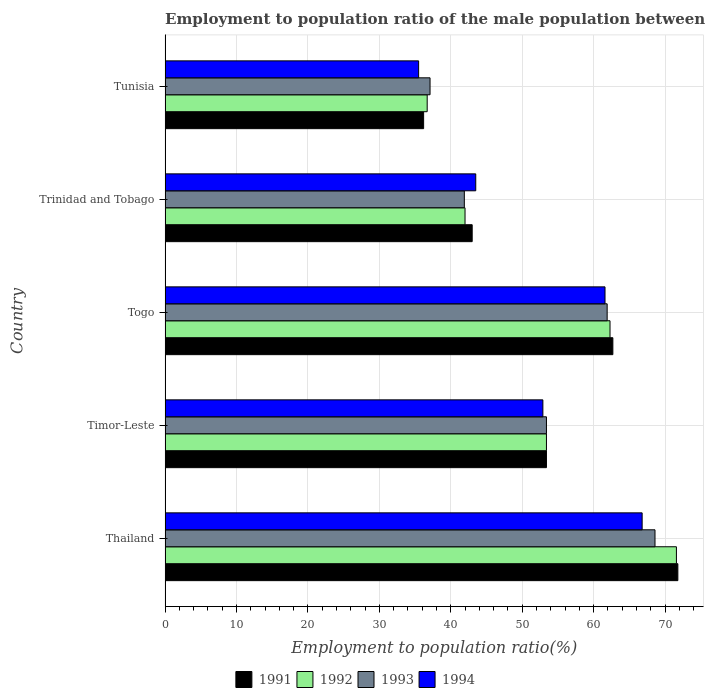How many different coloured bars are there?
Keep it short and to the point. 4. Are the number of bars per tick equal to the number of legend labels?
Ensure brevity in your answer.  Yes. What is the label of the 5th group of bars from the top?
Keep it short and to the point. Thailand. In how many cases, is the number of bars for a given country not equal to the number of legend labels?
Ensure brevity in your answer.  0. What is the employment to population ratio in 1992 in Timor-Leste?
Your response must be concise. 53.4. Across all countries, what is the maximum employment to population ratio in 1993?
Make the answer very short. 68.6. Across all countries, what is the minimum employment to population ratio in 1992?
Give a very brief answer. 36.7. In which country was the employment to population ratio in 1993 maximum?
Give a very brief answer. Thailand. In which country was the employment to population ratio in 1993 minimum?
Your answer should be very brief. Tunisia. What is the total employment to population ratio in 1991 in the graph?
Offer a very short reply. 267.1. What is the difference between the employment to population ratio in 1991 in Trinidad and Tobago and that in Tunisia?
Offer a terse response. 6.8. What is the difference between the employment to population ratio in 1992 in Timor-Leste and the employment to population ratio in 1993 in Trinidad and Tobago?
Keep it short and to the point. 11.5. What is the average employment to population ratio in 1994 per country?
Provide a succinct answer. 52.06. What is the difference between the employment to population ratio in 1991 and employment to population ratio in 1993 in Thailand?
Give a very brief answer. 3.2. What is the ratio of the employment to population ratio in 1993 in Thailand to that in Tunisia?
Provide a succinct answer. 1.85. Is the difference between the employment to population ratio in 1991 in Thailand and Togo greater than the difference between the employment to population ratio in 1993 in Thailand and Togo?
Your response must be concise. Yes. What is the difference between the highest and the second highest employment to population ratio in 1993?
Offer a very short reply. 6.7. What is the difference between the highest and the lowest employment to population ratio in 1993?
Offer a very short reply. 31.5. In how many countries, is the employment to population ratio in 1992 greater than the average employment to population ratio in 1992 taken over all countries?
Your answer should be compact. 3. Is the sum of the employment to population ratio in 1991 in Thailand and Togo greater than the maximum employment to population ratio in 1993 across all countries?
Ensure brevity in your answer.  Yes. What does the 1st bar from the bottom in Togo represents?
Offer a very short reply. 1991. Is it the case that in every country, the sum of the employment to population ratio in 1994 and employment to population ratio in 1992 is greater than the employment to population ratio in 1991?
Offer a terse response. Yes. Does the graph contain any zero values?
Your response must be concise. No. Does the graph contain grids?
Your response must be concise. Yes. How many legend labels are there?
Your answer should be compact. 4. What is the title of the graph?
Make the answer very short. Employment to population ratio of the male population between the ages 0 to 14. Does "1983" appear as one of the legend labels in the graph?
Keep it short and to the point. No. What is the Employment to population ratio(%) of 1991 in Thailand?
Ensure brevity in your answer.  71.8. What is the Employment to population ratio(%) in 1992 in Thailand?
Provide a short and direct response. 71.6. What is the Employment to population ratio(%) of 1993 in Thailand?
Offer a terse response. 68.6. What is the Employment to population ratio(%) of 1994 in Thailand?
Provide a succinct answer. 66.8. What is the Employment to population ratio(%) in 1991 in Timor-Leste?
Offer a very short reply. 53.4. What is the Employment to population ratio(%) of 1992 in Timor-Leste?
Offer a very short reply. 53.4. What is the Employment to population ratio(%) in 1993 in Timor-Leste?
Ensure brevity in your answer.  53.4. What is the Employment to population ratio(%) of 1994 in Timor-Leste?
Your answer should be very brief. 52.9. What is the Employment to population ratio(%) in 1991 in Togo?
Keep it short and to the point. 62.7. What is the Employment to population ratio(%) of 1992 in Togo?
Make the answer very short. 62.3. What is the Employment to population ratio(%) of 1993 in Togo?
Keep it short and to the point. 61.9. What is the Employment to population ratio(%) of 1994 in Togo?
Offer a terse response. 61.6. What is the Employment to population ratio(%) of 1991 in Trinidad and Tobago?
Your response must be concise. 43. What is the Employment to population ratio(%) of 1993 in Trinidad and Tobago?
Give a very brief answer. 41.9. What is the Employment to population ratio(%) of 1994 in Trinidad and Tobago?
Your response must be concise. 43.5. What is the Employment to population ratio(%) of 1991 in Tunisia?
Provide a succinct answer. 36.2. What is the Employment to population ratio(%) of 1992 in Tunisia?
Offer a very short reply. 36.7. What is the Employment to population ratio(%) in 1993 in Tunisia?
Your response must be concise. 37.1. What is the Employment to population ratio(%) in 1994 in Tunisia?
Provide a succinct answer. 35.5. Across all countries, what is the maximum Employment to population ratio(%) of 1991?
Your answer should be compact. 71.8. Across all countries, what is the maximum Employment to population ratio(%) in 1992?
Offer a very short reply. 71.6. Across all countries, what is the maximum Employment to population ratio(%) in 1993?
Your answer should be compact. 68.6. Across all countries, what is the maximum Employment to population ratio(%) in 1994?
Your answer should be very brief. 66.8. Across all countries, what is the minimum Employment to population ratio(%) of 1991?
Ensure brevity in your answer.  36.2. Across all countries, what is the minimum Employment to population ratio(%) in 1992?
Ensure brevity in your answer.  36.7. Across all countries, what is the minimum Employment to population ratio(%) of 1993?
Offer a very short reply. 37.1. Across all countries, what is the minimum Employment to population ratio(%) of 1994?
Provide a short and direct response. 35.5. What is the total Employment to population ratio(%) in 1991 in the graph?
Make the answer very short. 267.1. What is the total Employment to population ratio(%) in 1992 in the graph?
Your answer should be very brief. 266. What is the total Employment to population ratio(%) in 1993 in the graph?
Ensure brevity in your answer.  262.9. What is the total Employment to population ratio(%) in 1994 in the graph?
Provide a short and direct response. 260.3. What is the difference between the Employment to population ratio(%) in 1992 in Thailand and that in Timor-Leste?
Your answer should be very brief. 18.2. What is the difference between the Employment to population ratio(%) of 1991 in Thailand and that in Togo?
Your response must be concise. 9.1. What is the difference between the Employment to population ratio(%) in 1992 in Thailand and that in Togo?
Provide a succinct answer. 9.3. What is the difference between the Employment to population ratio(%) of 1994 in Thailand and that in Togo?
Provide a short and direct response. 5.2. What is the difference between the Employment to population ratio(%) in 1991 in Thailand and that in Trinidad and Tobago?
Make the answer very short. 28.8. What is the difference between the Employment to population ratio(%) of 1992 in Thailand and that in Trinidad and Tobago?
Offer a very short reply. 29.6. What is the difference between the Employment to population ratio(%) of 1993 in Thailand and that in Trinidad and Tobago?
Provide a short and direct response. 26.7. What is the difference between the Employment to population ratio(%) in 1994 in Thailand and that in Trinidad and Tobago?
Your response must be concise. 23.3. What is the difference between the Employment to population ratio(%) of 1991 in Thailand and that in Tunisia?
Make the answer very short. 35.6. What is the difference between the Employment to population ratio(%) of 1992 in Thailand and that in Tunisia?
Provide a short and direct response. 34.9. What is the difference between the Employment to population ratio(%) of 1993 in Thailand and that in Tunisia?
Keep it short and to the point. 31.5. What is the difference between the Employment to population ratio(%) of 1994 in Thailand and that in Tunisia?
Offer a terse response. 31.3. What is the difference between the Employment to population ratio(%) of 1993 in Timor-Leste and that in Togo?
Provide a short and direct response. -8.5. What is the difference between the Employment to population ratio(%) in 1994 in Timor-Leste and that in Togo?
Your response must be concise. -8.7. What is the difference between the Employment to population ratio(%) of 1991 in Timor-Leste and that in Trinidad and Tobago?
Keep it short and to the point. 10.4. What is the difference between the Employment to population ratio(%) of 1992 in Timor-Leste and that in Trinidad and Tobago?
Ensure brevity in your answer.  11.4. What is the difference between the Employment to population ratio(%) in 1993 in Timor-Leste and that in Trinidad and Tobago?
Ensure brevity in your answer.  11.5. What is the difference between the Employment to population ratio(%) of 1992 in Timor-Leste and that in Tunisia?
Keep it short and to the point. 16.7. What is the difference between the Employment to population ratio(%) of 1993 in Timor-Leste and that in Tunisia?
Offer a terse response. 16.3. What is the difference between the Employment to population ratio(%) in 1991 in Togo and that in Trinidad and Tobago?
Provide a short and direct response. 19.7. What is the difference between the Employment to population ratio(%) in 1992 in Togo and that in Trinidad and Tobago?
Make the answer very short. 20.3. What is the difference between the Employment to population ratio(%) in 1993 in Togo and that in Trinidad and Tobago?
Keep it short and to the point. 20. What is the difference between the Employment to population ratio(%) in 1992 in Togo and that in Tunisia?
Your answer should be very brief. 25.6. What is the difference between the Employment to population ratio(%) in 1993 in Togo and that in Tunisia?
Give a very brief answer. 24.8. What is the difference between the Employment to population ratio(%) of 1994 in Togo and that in Tunisia?
Give a very brief answer. 26.1. What is the difference between the Employment to population ratio(%) of 1991 in Trinidad and Tobago and that in Tunisia?
Make the answer very short. 6.8. What is the difference between the Employment to population ratio(%) in 1991 in Thailand and the Employment to population ratio(%) in 1994 in Timor-Leste?
Your answer should be compact. 18.9. What is the difference between the Employment to population ratio(%) in 1992 in Thailand and the Employment to population ratio(%) in 1993 in Timor-Leste?
Give a very brief answer. 18.2. What is the difference between the Employment to population ratio(%) of 1992 in Thailand and the Employment to population ratio(%) of 1994 in Timor-Leste?
Keep it short and to the point. 18.7. What is the difference between the Employment to population ratio(%) of 1991 in Thailand and the Employment to population ratio(%) of 1992 in Togo?
Keep it short and to the point. 9.5. What is the difference between the Employment to population ratio(%) of 1991 in Thailand and the Employment to population ratio(%) of 1994 in Togo?
Your response must be concise. 10.2. What is the difference between the Employment to population ratio(%) of 1992 in Thailand and the Employment to population ratio(%) of 1993 in Togo?
Keep it short and to the point. 9.7. What is the difference between the Employment to population ratio(%) of 1991 in Thailand and the Employment to population ratio(%) of 1992 in Trinidad and Tobago?
Offer a terse response. 29.8. What is the difference between the Employment to population ratio(%) in 1991 in Thailand and the Employment to population ratio(%) in 1993 in Trinidad and Tobago?
Offer a very short reply. 29.9. What is the difference between the Employment to population ratio(%) in 1991 in Thailand and the Employment to population ratio(%) in 1994 in Trinidad and Tobago?
Offer a very short reply. 28.3. What is the difference between the Employment to population ratio(%) of 1992 in Thailand and the Employment to population ratio(%) of 1993 in Trinidad and Tobago?
Your answer should be very brief. 29.7. What is the difference between the Employment to population ratio(%) in 1992 in Thailand and the Employment to population ratio(%) in 1994 in Trinidad and Tobago?
Your answer should be compact. 28.1. What is the difference between the Employment to population ratio(%) of 1993 in Thailand and the Employment to population ratio(%) of 1994 in Trinidad and Tobago?
Keep it short and to the point. 25.1. What is the difference between the Employment to population ratio(%) in 1991 in Thailand and the Employment to population ratio(%) in 1992 in Tunisia?
Keep it short and to the point. 35.1. What is the difference between the Employment to population ratio(%) of 1991 in Thailand and the Employment to population ratio(%) of 1993 in Tunisia?
Give a very brief answer. 34.7. What is the difference between the Employment to population ratio(%) in 1991 in Thailand and the Employment to population ratio(%) in 1994 in Tunisia?
Give a very brief answer. 36.3. What is the difference between the Employment to population ratio(%) of 1992 in Thailand and the Employment to population ratio(%) of 1993 in Tunisia?
Give a very brief answer. 34.5. What is the difference between the Employment to population ratio(%) in 1992 in Thailand and the Employment to population ratio(%) in 1994 in Tunisia?
Offer a very short reply. 36.1. What is the difference between the Employment to population ratio(%) of 1993 in Thailand and the Employment to population ratio(%) of 1994 in Tunisia?
Your response must be concise. 33.1. What is the difference between the Employment to population ratio(%) in 1991 in Timor-Leste and the Employment to population ratio(%) in 1992 in Togo?
Your response must be concise. -8.9. What is the difference between the Employment to population ratio(%) in 1992 in Timor-Leste and the Employment to population ratio(%) in 1993 in Togo?
Offer a terse response. -8.5. What is the difference between the Employment to population ratio(%) in 1992 in Timor-Leste and the Employment to population ratio(%) in 1994 in Togo?
Your response must be concise. -8.2. What is the difference between the Employment to population ratio(%) in 1991 in Timor-Leste and the Employment to population ratio(%) in 1992 in Trinidad and Tobago?
Make the answer very short. 11.4. What is the difference between the Employment to population ratio(%) of 1992 in Timor-Leste and the Employment to population ratio(%) of 1994 in Trinidad and Tobago?
Your response must be concise. 9.9. What is the difference between the Employment to population ratio(%) in 1993 in Timor-Leste and the Employment to population ratio(%) in 1994 in Trinidad and Tobago?
Your answer should be compact. 9.9. What is the difference between the Employment to population ratio(%) of 1991 in Timor-Leste and the Employment to population ratio(%) of 1993 in Tunisia?
Make the answer very short. 16.3. What is the difference between the Employment to population ratio(%) in 1991 in Timor-Leste and the Employment to population ratio(%) in 1994 in Tunisia?
Keep it short and to the point. 17.9. What is the difference between the Employment to population ratio(%) in 1992 in Timor-Leste and the Employment to population ratio(%) in 1994 in Tunisia?
Keep it short and to the point. 17.9. What is the difference between the Employment to population ratio(%) of 1991 in Togo and the Employment to population ratio(%) of 1992 in Trinidad and Tobago?
Your answer should be very brief. 20.7. What is the difference between the Employment to population ratio(%) of 1991 in Togo and the Employment to population ratio(%) of 1993 in Trinidad and Tobago?
Your answer should be compact. 20.8. What is the difference between the Employment to population ratio(%) in 1991 in Togo and the Employment to population ratio(%) in 1994 in Trinidad and Tobago?
Keep it short and to the point. 19.2. What is the difference between the Employment to population ratio(%) of 1992 in Togo and the Employment to population ratio(%) of 1993 in Trinidad and Tobago?
Offer a terse response. 20.4. What is the difference between the Employment to population ratio(%) in 1993 in Togo and the Employment to population ratio(%) in 1994 in Trinidad and Tobago?
Keep it short and to the point. 18.4. What is the difference between the Employment to population ratio(%) of 1991 in Togo and the Employment to population ratio(%) of 1992 in Tunisia?
Ensure brevity in your answer.  26. What is the difference between the Employment to population ratio(%) of 1991 in Togo and the Employment to population ratio(%) of 1993 in Tunisia?
Give a very brief answer. 25.6. What is the difference between the Employment to population ratio(%) of 1991 in Togo and the Employment to population ratio(%) of 1994 in Tunisia?
Offer a very short reply. 27.2. What is the difference between the Employment to population ratio(%) of 1992 in Togo and the Employment to population ratio(%) of 1993 in Tunisia?
Provide a short and direct response. 25.2. What is the difference between the Employment to population ratio(%) of 1992 in Togo and the Employment to population ratio(%) of 1994 in Tunisia?
Your answer should be very brief. 26.8. What is the difference between the Employment to population ratio(%) of 1993 in Togo and the Employment to population ratio(%) of 1994 in Tunisia?
Ensure brevity in your answer.  26.4. What is the difference between the Employment to population ratio(%) in 1992 in Trinidad and Tobago and the Employment to population ratio(%) in 1994 in Tunisia?
Ensure brevity in your answer.  6.5. What is the difference between the Employment to population ratio(%) of 1993 in Trinidad and Tobago and the Employment to population ratio(%) of 1994 in Tunisia?
Offer a very short reply. 6.4. What is the average Employment to population ratio(%) of 1991 per country?
Keep it short and to the point. 53.42. What is the average Employment to population ratio(%) in 1992 per country?
Give a very brief answer. 53.2. What is the average Employment to population ratio(%) in 1993 per country?
Provide a short and direct response. 52.58. What is the average Employment to population ratio(%) in 1994 per country?
Provide a succinct answer. 52.06. What is the difference between the Employment to population ratio(%) in 1991 and Employment to population ratio(%) in 1993 in Thailand?
Your answer should be compact. 3.2. What is the difference between the Employment to population ratio(%) of 1992 and Employment to population ratio(%) of 1993 in Thailand?
Provide a succinct answer. 3. What is the difference between the Employment to population ratio(%) of 1992 and Employment to population ratio(%) of 1994 in Thailand?
Offer a terse response. 4.8. What is the difference between the Employment to population ratio(%) in 1993 and Employment to population ratio(%) in 1994 in Thailand?
Keep it short and to the point. 1.8. What is the difference between the Employment to population ratio(%) in 1991 and Employment to population ratio(%) in 1993 in Timor-Leste?
Make the answer very short. 0. What is the difference between the Employment to population ratio(%) of 1991 and Employment to population ratio(%) of 1994 in Timor-Leste?
Offer a terse response. 0.5. What is the difference between the Employment to population ratio(%) of 1992 and Employment to population ratio(%) of 1994 in Timor-Leste?
Your answer should be very brief. 0.5. What is the difference between the Employment to population ratio(%) in 1993 and Employment to population ratio(%) in 1994 in Timor-Leste?
Ensure brevity in your answer.  0.5. What is the difference between the Employment to population ratio(%) of 1992 and Employment to population ratio(%) of 1994 in Togo?
Offer a terse response. 0.7. What is the difference between the Employment to population ratio(%) in 1991 and Employment to population ratio(%) in 1992 in Trinidad and Tobago?
Provide a succinct answer. 1. What is the difference between the Employment to population ratio(%) of 1991 and Employment to population ratio(%) of 1994 in Trinidad and Tobago?
Provide a short and direct response. -0.5. What is the difference between the Employment to population ratio(%) of 1992 and Employment to population ratio(%) of 1994 in Trinidad and Tobago?
Provide a short and direct response. -1.5. What is the difference between the Employment to population ratio(%) of 1991 and Employment to population ratio(%) of 1994 in Tunisia?
Your answer should be very brief. 0.7. What is the difference between the Employment to population ratio(%) in 1992 and Employment to population ratio(%) in 1993 in Tunisia?
Ensure brevity in your answer.  -0.4. What is the ratio of the Employment to population ratio(%) in 1991 in Thailand to that in Timor-Leste?
Provide a short and direct response. 1.34. What is the ratio of the Employment to population ratio(%) of 1992 in Thailand to that in Timor-Leste?
Provide a succinct answer. 1.34. What is the ratio of the Employment to population ratio(%) of 1993 in Thailand to that in Timor-Leste?
Provide a succinct answer. 1.28. What is the ratio of the Employment to population ratio(%) in 1994 in Thailand to that in Timor-Leste?
Keep it short and to the point. 1.26. What is the ratio of the Employment to population ratio(%) of 1991 in Thailand to that in Togo?
Offer a terse response. 1.15. What is the ratio of the Employment to population ratio(%) of 1992 in Thailand to that in Togo?
Your answer should be compact. 1.15. What is the ratio of the Employment to population ratio(%) of 1993 in Thailand to that in Togo?
Offer a very short reply. 1.11. What is the ratio of the Employment to population ratio(%) in 1994 in Thailand to that in Togo?
Keep it short and to the point. 1.08. What is the ratio of the Employment to population ratio(%) in 1991 in Thailand to that in Trinidad and Tobago?
Make the answer very short. 1.67. What is the ratio of the Employment to population ratio(%) in 1992 in Thailand to that in Trinidad and Tobago?
Give a very brief answer. 1.7. What is the ratio of the Employment to population ratio(%) in 1993 in Thailand to that in Trinidad and Tobago?
Give a very brief answer. 1.64. What is the ratio of the Employment to population ratio(%) of 1994 in Thailand to that in Trinidad and Tobago?
Your response must be concise. 1.54. What is the ratio of the Employment to population ratio(%) in 1991 in Thailand to that in Tunisia?
Your answer should be compact. 1.98. What is the ratio of the Employment to population ratio(%) in 1992 in Thailand to that in Tunisia?
Give a very brief answer. 1.95. What is the ratio of the Employment to population ratio(%) of 1993 in Thailand to that in Tunisia?
Provide a succinct answer. 1.85. What is the ratio of the Employment to population ratio(%) in 1994 in Thailand to that in Tunisia?
Provide a succinct answer. 1.88. What is the ratio of the Employment to population ratio(%) in 1991 in Timor-Leste to that in Togo?
Provide a short and direct response. 0.85. What is the ratio of the Employment to population ratio(%) in 1993 in Timor-Leste to that in Togo?
Your response must be concise. 0.86. What is the ratio of the Employment to population ratio(%) of 1994 in Timor-Leste to that in Togo?
Offer a terse response. 0.86. What is the ratio of the Employment to population ratio(%) in 1991 in Timor-Leste to that in Trinidad and Tobago?
Keep it short and to the point. 1.24. What is the ratio of the Employment to population ratio(%) in 1992 in Timor-Leste to that in Trinidad and Tobago?
Ensure brevity in your answer.  1.27. What is the ratio of the Employment to population ratio(%) of 1993 in Timor-Leste to that in Trinidad and Tobago?
Keep it short and to the point. 1.27. What is the ratio of the Employment to population ratio(%) of 1994 in Timor-Leste to that in Trinidad and Tobago?
Offer a very short reply. 1.22. What is the ratio of the Employment to population ratio(%) in 1991 in Timor-Leste to that in Tunisia?
Provide a short and direct response. 1.48. What is the ratio of the Employment to population ratio(%) in 1992 in Timor-Leste to that in Tunisia?
Your response must be concise. 1.46. What is the ratio of the Employment to population ratio(%) of 1993 in Timor-Leste to that in Tunisia?
Give a very brief answer. 1.44. What is the ratio of the Employment to population ratio(%) of 1994 in Timor-Leste to that in Tunisia?
Offer a very short reply. 1.49. What is the ratio of the Employment to population ratio(%) of 1991 in Togo to that in Trinidad and Tobago?
Provide a short and direct response. 1.46. What is the ratio of the Employment to population ratio(%) in 1992 in Togo to that in Trinidad and Tobago?
Ensure brevity in your answer.  1.48. What is the ratio of the Employment to population ratio(%) in 1993 in Togo to that in Trinidad and Tobago?
Offer a terse response. 1.48. What is the ratio of the Employment to population ratio(%) in 1994 in Togo to that in Trinidad and Tobago?
Your response must be concise. 1.42. What is the ratio of the Employment to population ratio(%) of 1991 in Togo to that in Tunisia?
Offer a very short reply. 1.73. What is the ratio of the Employment to population ratio(%) of 1992 in Togo to that in Tunisia?
Your answer should be compact. 1.7. What is the ratio of the Employment to population ratio(%) of 1993 in Togo to that in Tunisia?
Make the answer very short. 1.67. What is the ratio of the Employment to population ratio(%) of 1994 in Togo to that in Tunisia?
Your answer should be compact. 1.74. What is the ratio of the Employment to population ratio(%) in 1991 in Trinidad and Tobago to that in Tunisia?
Offer a very short reply. 1.19. What is the ratio of the Employment to population ratio(%) of 1992 in Trinidad and Tobago to that in Tunisia?
Your answer should be very brief. 1.14. What is the ratio of the Employment to population ratio(%) of 1993 in Trinidad and Tobago to that in Tunisia?
Your answer should be compact. 1.13. What is the ratio of the Employment to population ratio(%) in 1994 in Trinidad and Tobago to that in Tunisia?
Your answer should be very brief. 1.23. What is the difference between the highest and the second highest Employment to population ratio(%) of 1991?
Your answer should be compact. 9.1. What is the difference between the highest and the second highest Employment to population ratio(%) in 1992?
Provide a succinct answer. 9.3. What is the difference between the highest and the second highest Employment to population ratio(%) in 1993?
Provide a short and direct response. 6.7. What is the difference between the highest and the lowest Employment to population ratio(%) in 1991?
Your answer should be very brief. 35.6. What is the difference between the highest and the lowest Employment to population ratio(%) in 1992?
Ensure brevity in your answer.  34.9. What is the difference between the highest and the lowest Employment to population ratio(%) in 1993?
Your answer should be compact. 31.5. What is the difference between the highest and the lowest Employment to population ratio(%) of 1994?
Ensure brevity in your answer.  31.3. 